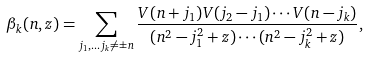Convert formula to latex. <formula><loc_0><loc_0><loc_500><loc_500>\beta _ { k } ( n , z ) = \sum _ { j _ { 1 } , \dots j _ { k } \neq \pm n } \frac { V ( n + j _ { 1 } ) V ( j _ { 2 } - j _ { 1 } ) \cdots V ( n - j _ { k } ) } { ( n ^ { 2 } - j _ { 1 } ^ { 2 } + z ) \cdots ( n ^ { 2 } - j _ { k } ^ { 2 } + z ) } ,</formula> 